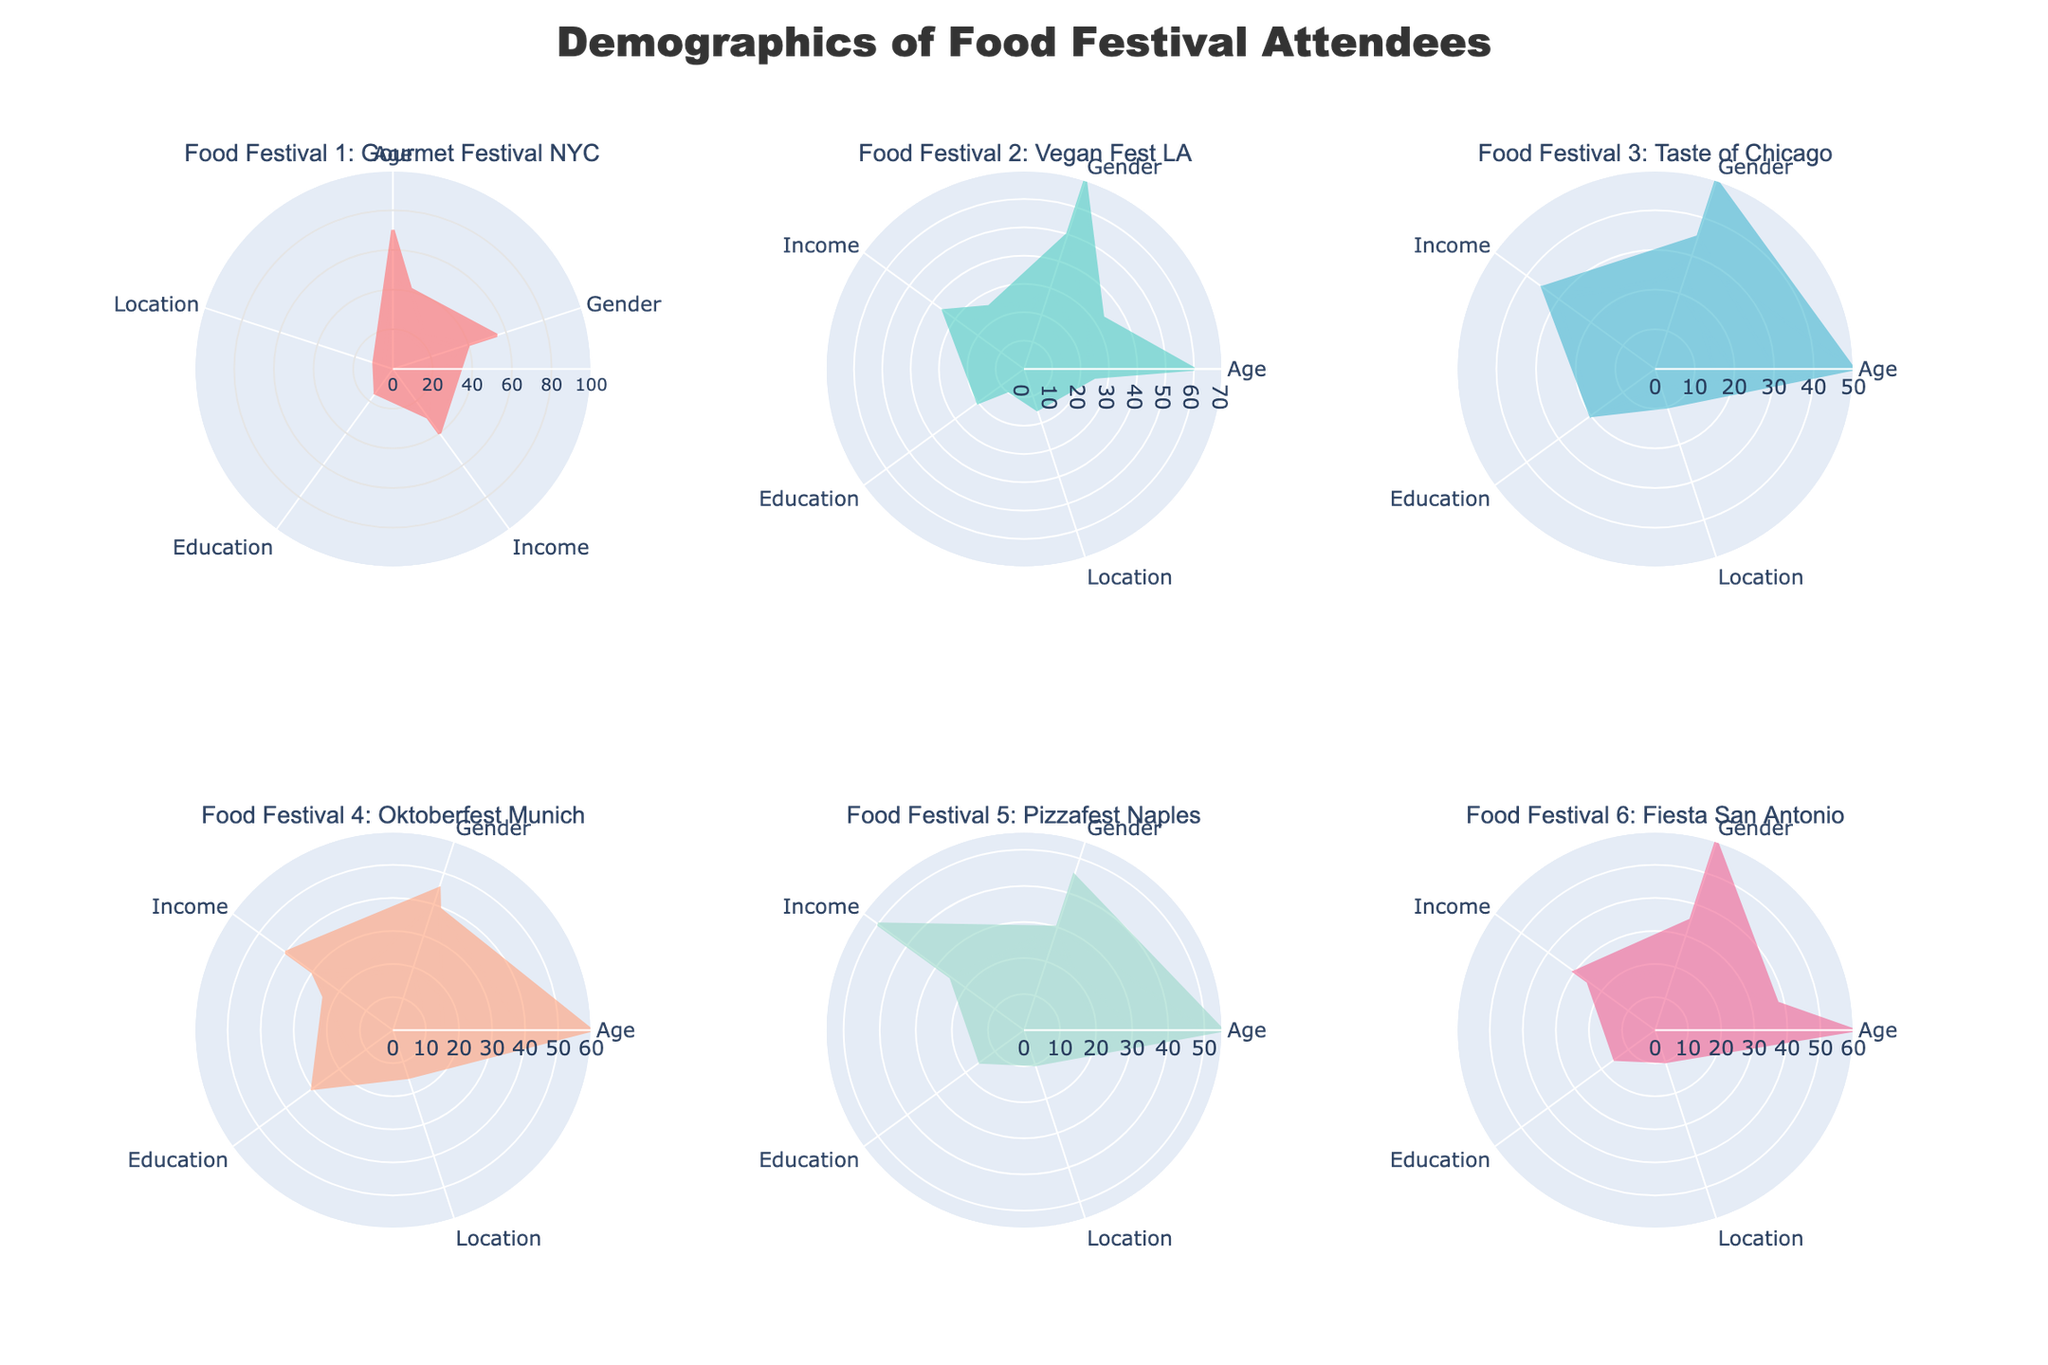Which food festival has the highest percentage of attendees aged 26-35? The radar chart displays demographic data for each food festival. By comparing the percentages for those aged 26-35 across different subplots, "Gourmet Festival NYC" has the highest with 35%.
Answer: Gourmet Festival NYC Which festival has the most even gender distribution? To determine the most even gender distribution, examine the Male and Female percentages for each festival. "Taste of Chicago" shows an even 50-50 distribution.
Answer: Taste of Chicago What is the predominant income level of attendees at the Vegan Fest LA? Looking at the income level section of the radar chart for Vegan Fest LA, attendees are mostly distributed within the "Income 50K-100K" range, at 50%.
Answer: Income 50K-100K Which festival has the highest proportion of attendees with a Bachelor's Degree? The radar chart displays educational level distributions for each festival. By examining the Bachelor's Degree segment, Vegan Fest LA has the highest proportion at 35%.
Answer: Vegan Fest LA How does the percentage of Urban attendees at Fiesta San Antonio compare to that at Gourmet Festival NYC? Scan both subplots to locate the Urban percentage. Fiesta San Antonio has 60%, while Gourmet Festival NYC has 70%. Subtract the smaller percentage from the larger one: 70% - 60% = 10%.
Answer: 10% Which festival has the highest percentage of attendees over the age of 56+? By comparing the elderly age group across all subplots, Vegan Fest LA has the highest percentage with 15%.
Answer: Vegan Fest LA What is the average percentage of attendees with Associate Degrees across all festivals? Each festival's subplot has an Associate Degree segment. Summing these percentages: 20 + 25 + 20 + 20 + 25 + 20 = 130. Dividing by 6 festivals gives an average: 130 / 6 ≈ 21.67%.
Answer: 21.67% Which festival's attendees are predominantly from Rural areas? By examining the Rural distribution in each subplot, "Taste of Chicago" and "Oktoberfest Munich" both have the highest Rural percentage at 20%.
Answer: Taste of Chicago and Oktoberfest Munich What is the combined percentage of attendees in the age group 18-25 for Pizzafest Naples and Fiesta San Antonio? Identify the 18-25 age group for these festivals: Pizzafest Naples has 20% and Fiesta San Antonio has 25%. Adding these: 20% + 25% = 45%.
Answer: 45% Which festival is attended by a higher percentage of people with Doctorates, Oktoberfest Munich or Fiesta San Antonio? Comparing the Doctorate percentages, both of these festivals have 10%.
Answer: Equal 